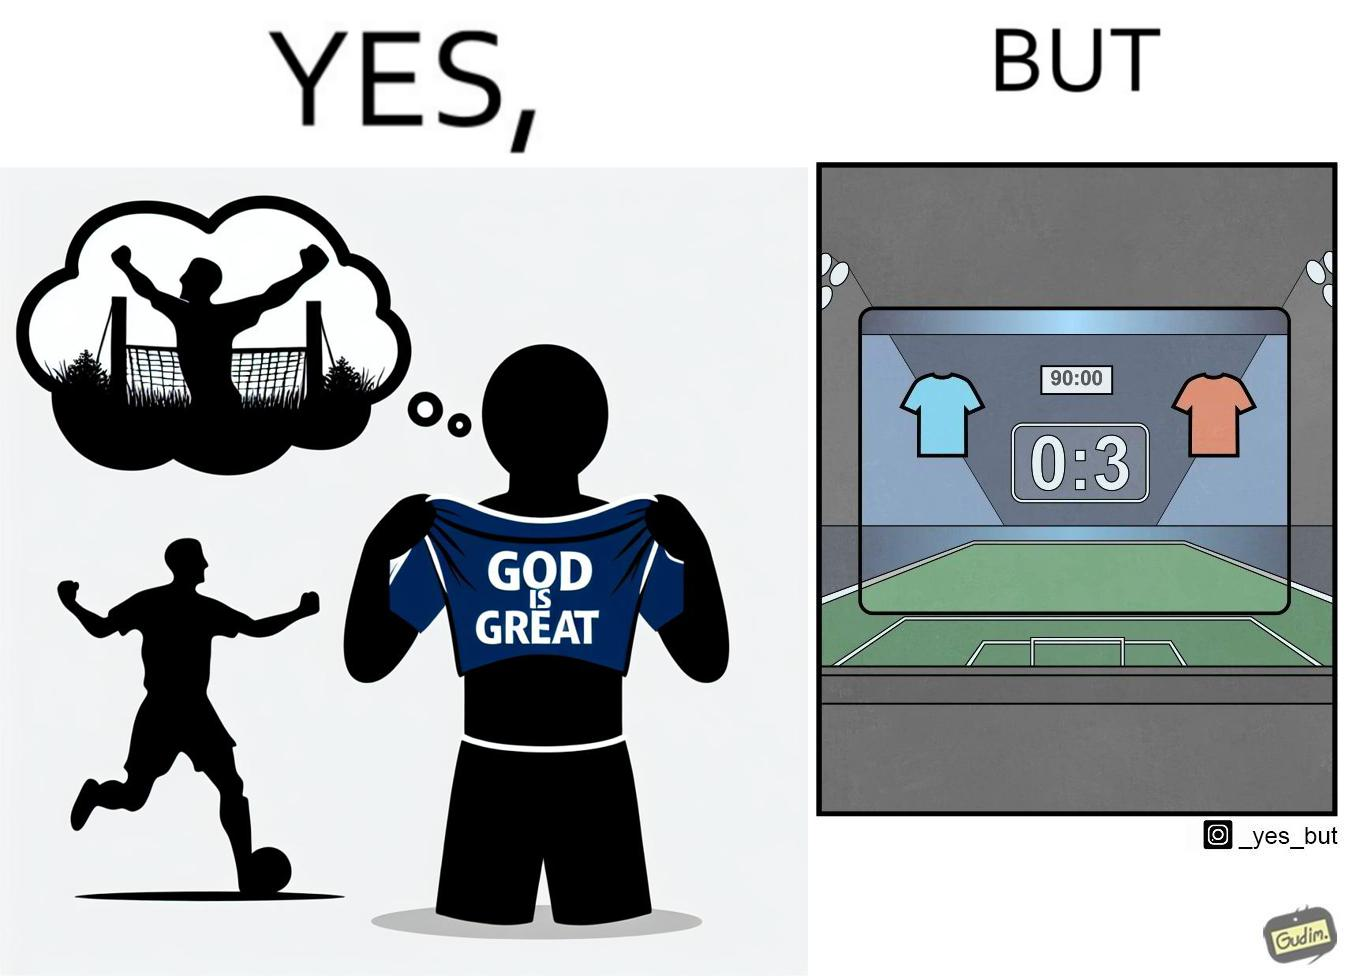Would you classify this image as satirical? Yes, this image is satirical. 